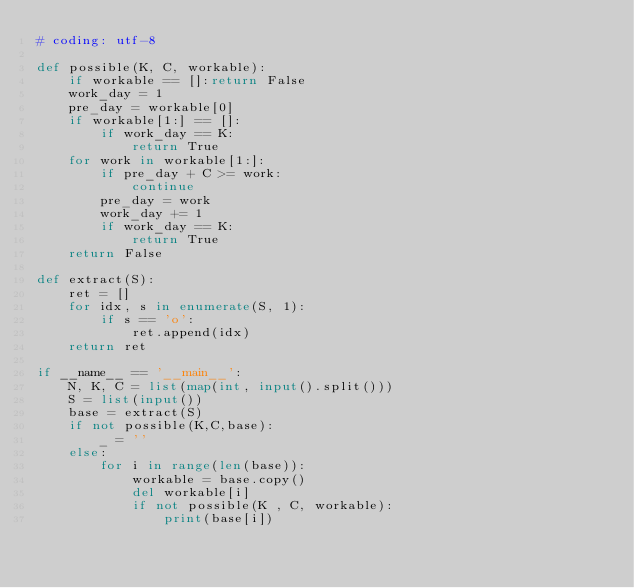Convert code to text. <code><loc_0><loc_0><loc_500><loc_500><_Python_># coding: utf-8

def possible(K, C, workable):
    if workable == []:return False
    work_day = 1
    pre_day = workable[0]
    if workable[1:] == []:
        if work_day == K:
            return True
    for work in workable[1:]:
        if pre_day + C >= work:
            continue
        pre_day = work
        work_day += 1
        if work_day == K:
            return True
    return False

def extract(S):
    ret = []
    for idx, s in enumerate(S, 1):
        if s == 'o':
            ret.append(idx)
    return ret

if __name__ == '__main__':
    N, K, C = list(map(int, input().split()))
    S = list(input())
    base = extract(S)
    if not possible(K,C,base):
        _ = ''
    else:
        for i in range(len(base)):
            workable = base.copy()
            del workable[i]
            if not possible(K , C, workable):
                print(base[i])</code> 